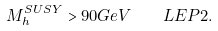<formula> <loc_0><loc_0><loc_500><loc_500>M _ { h } ^ { S U S Y } > 9 0 G e V \quad L E P 2 .</formula> 